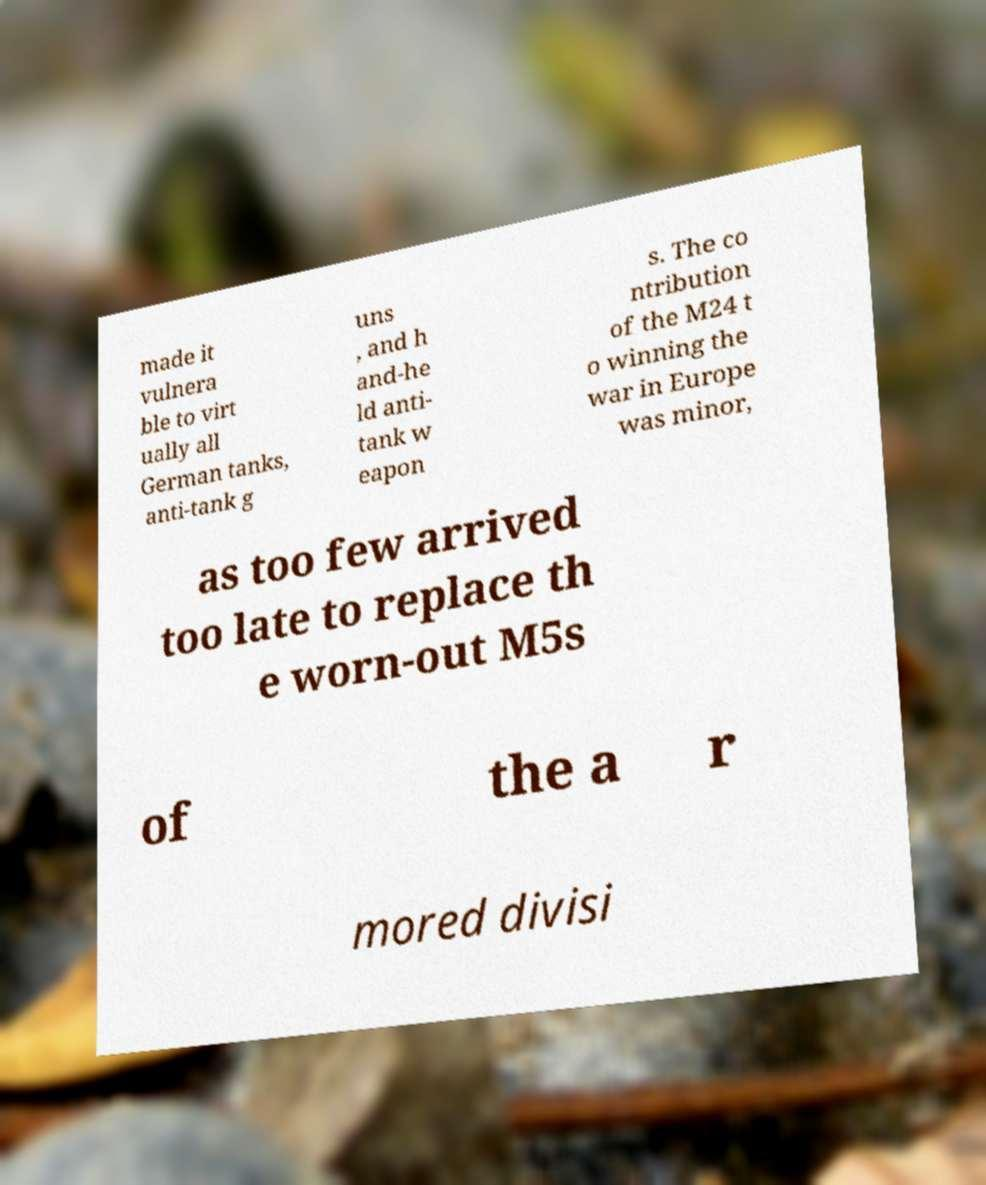I need the written content from this picture converted into text. Can you do that? made it vulnera ble to virt ually all German tanks, anti-tank g uns , and h and-he ld anti- tank w eapon s. The co ntribution of the M24 t o winning the war in Europe was minor, as too few arrived too late to replace th e worn-out M5s of the a r mored divisi 